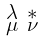Convert formula to latex. <formula><loc_0><loc_0><loc_500><loc_500>\begin{smallmatrix} \lambda & \ast \\ \mu & \nu \end{smallmatrix}</formula> 